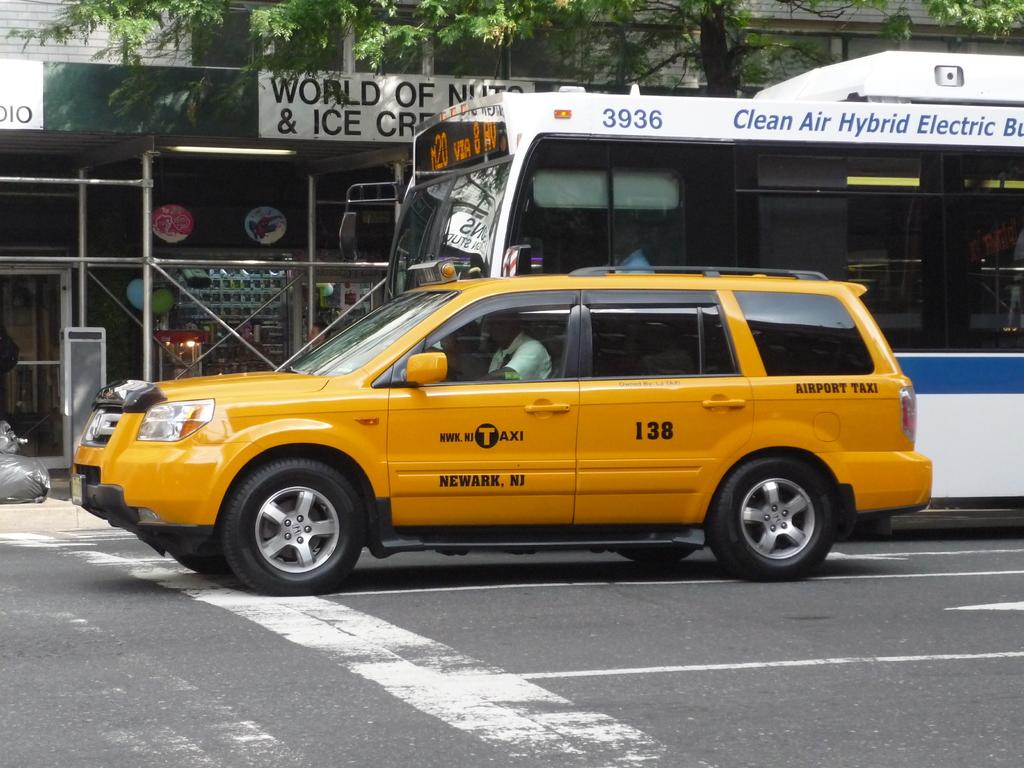<image>
Provide a brief description of the given image. A taxi SUV next to a city bus that says Clean Air Hybrid Electric across the top. 